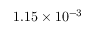<formula> <loc_0><loc_0><loc_500><loc_500>1 . 1 5 \times 1 0 ^ { - 3 }</formula> 